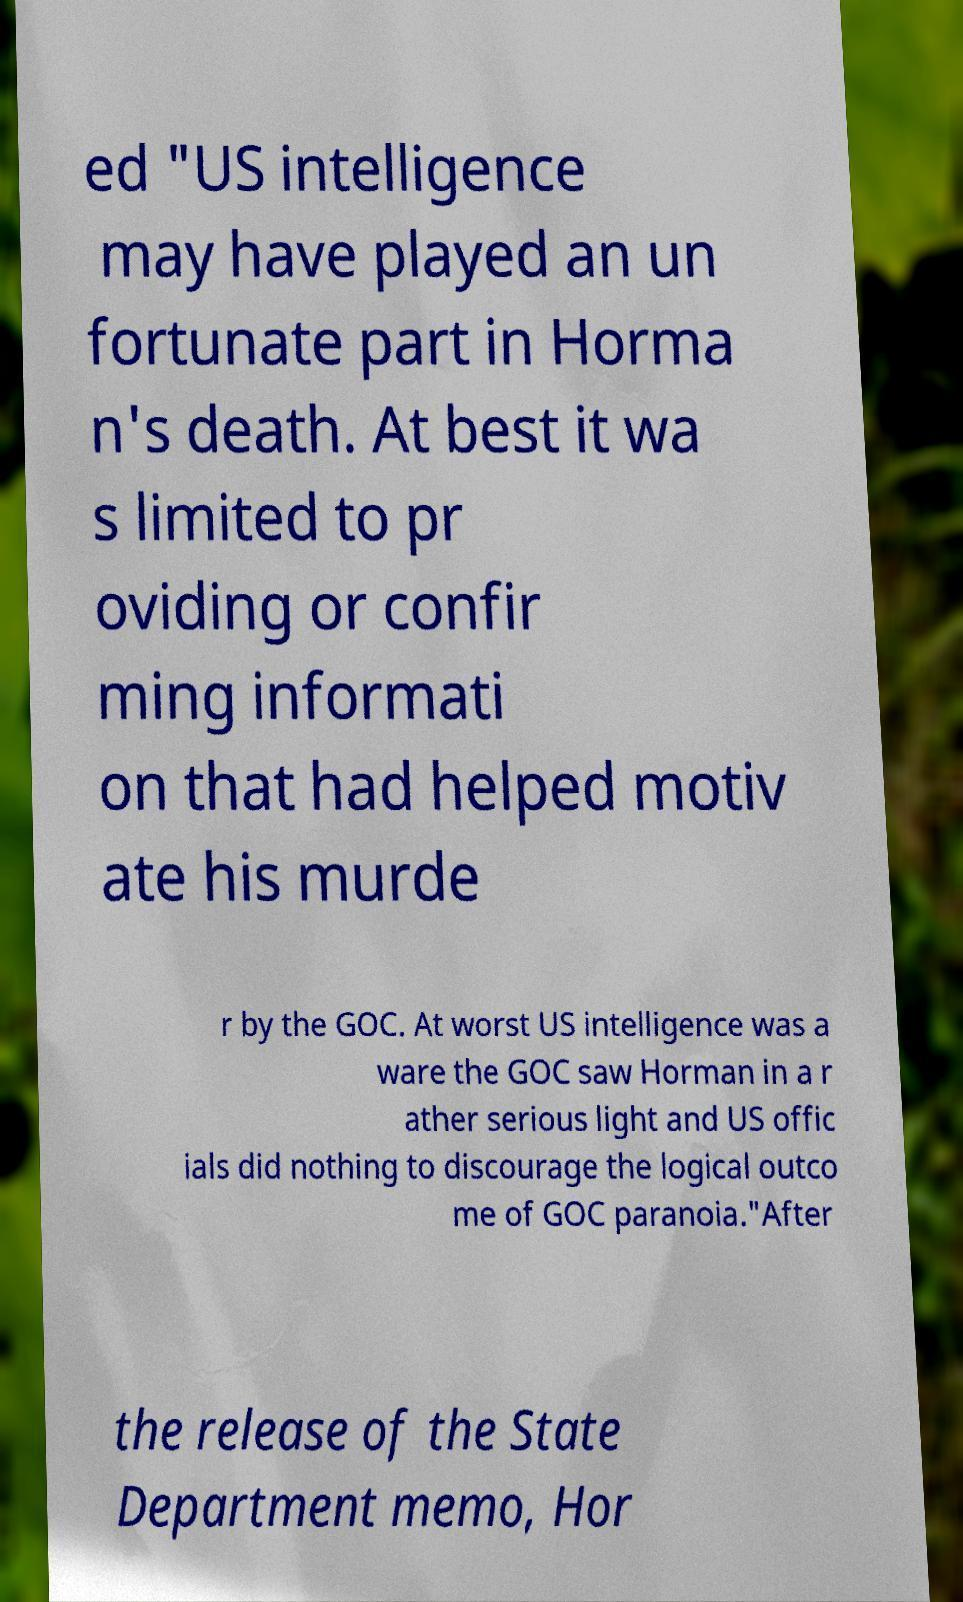I need the written content from this picture converted into text. Can you do that? ed "US intelligence may have played an un fortunate part in Horma n's death. At best it wa s limited to pr oviding or confir ming informati on that had helped motiv ate his murde r by the GOC. At worst US intelligence was a ware the GOC saw Horman in a r ather serious light and US offic ials did nothing to discourage the logical outco me of GOC paranoia."After the release of the State Department memo, Hor 